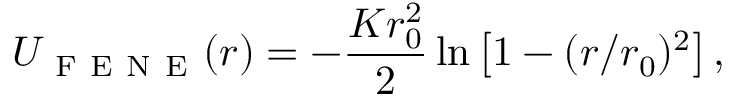Convert formula to latex. <formula><loc_0><loc_0><loc_500><loc_500>U _ { F E N E } ( r ) = - \frac { K r _ { 0 } ^ { 2 } } 2 \ln \left [ 1 - ( r / r _ { 0 } ) ^ { 2 } \right ] ,</formula> 